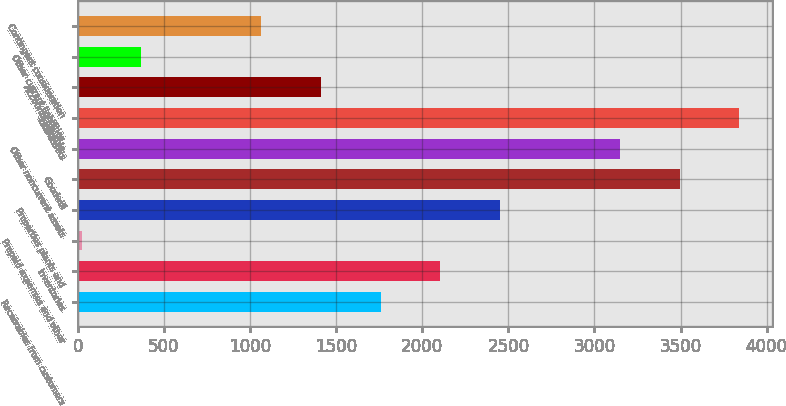Convert chart to OTSL. <chart><loc_0><loc_0><loc_500><loc_500><bar_chart><fcel>Receivables from customers<fcel>Inventories<fcel>Prepaid expenses and other<fcel>Properties plants and<fcel>Goodwill<fcel>Other noncurrent assets<fcel>Total assets<fcel>Accounts payable<fcel>Other current liabilities<fcel>Contingent consideration<nl><fcel>1758<fcel>2105.2<fcel>22<fcel>2452.4<fcel>3494<fcel>3146.8<fcel>3841.2<fcel>1410.8<fcel>369.2<fcel>1063.6<nl></chart> 